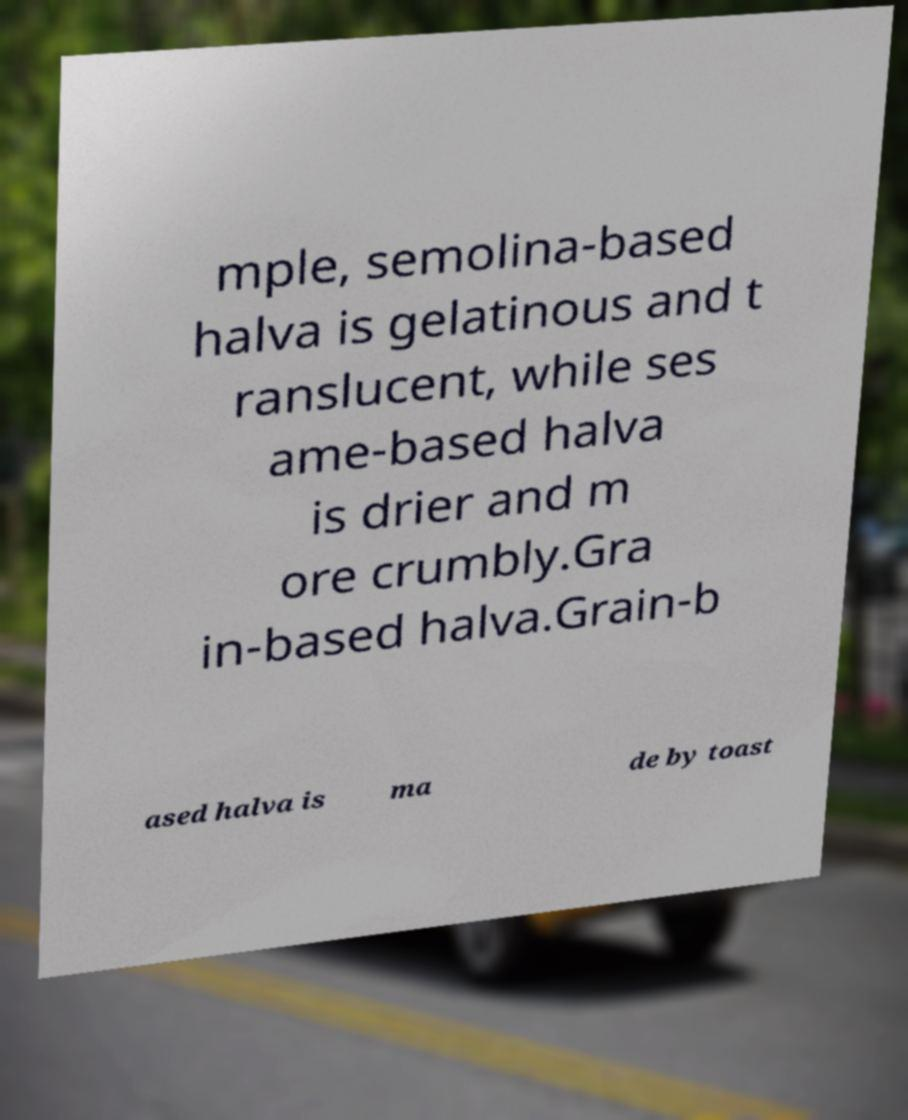Could you assist in decoding the text presented in this image and type it out clearly? mple, semolina-based halva is gelatinous and t ranslucent, while ses ame-based halva is drier and m ore crumbly.Gra in-based halva.Grain-b ased halva is ma de by toast 